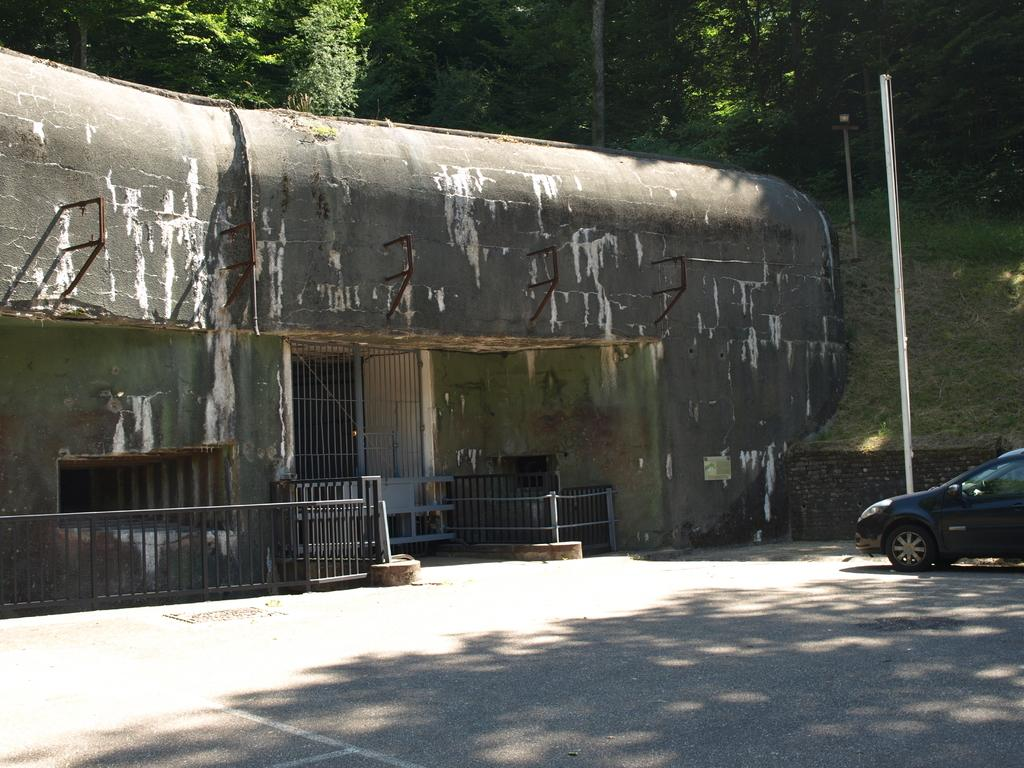What type of structure is in the image? There is an old building in the image. What feature is present on the building? The building has an iron gate. What object can be seen in the image besides the building? There is a pole in the image. What is located on the right side of the image? There is a car on the right side of the image. What can be seen in the background of the image? There are trees in the background of the image. What type of prose is being written on the building in the image? There is no prose visible on the building in the image. What relation does the car have to the trees in the image? The car and trees are separate objects in the image and do not have a direct relation to each other. 